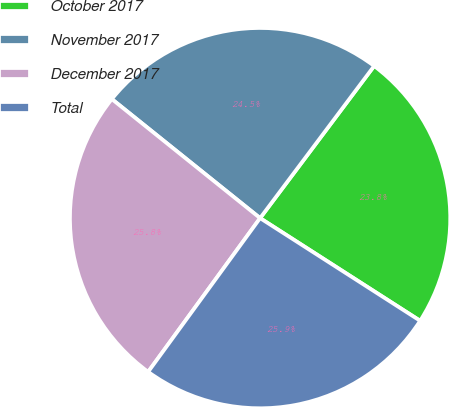<chart> <loc_0><loc_0><loc_500><loc_500><pie_chart><fcel>October 2017<fcel>November 2017<fcel>December 2017<fcel>Total<nl><fcel>23.84%<fcel>24.47%<fcel>25.75%<fcel>25.94%<nl></chart> 